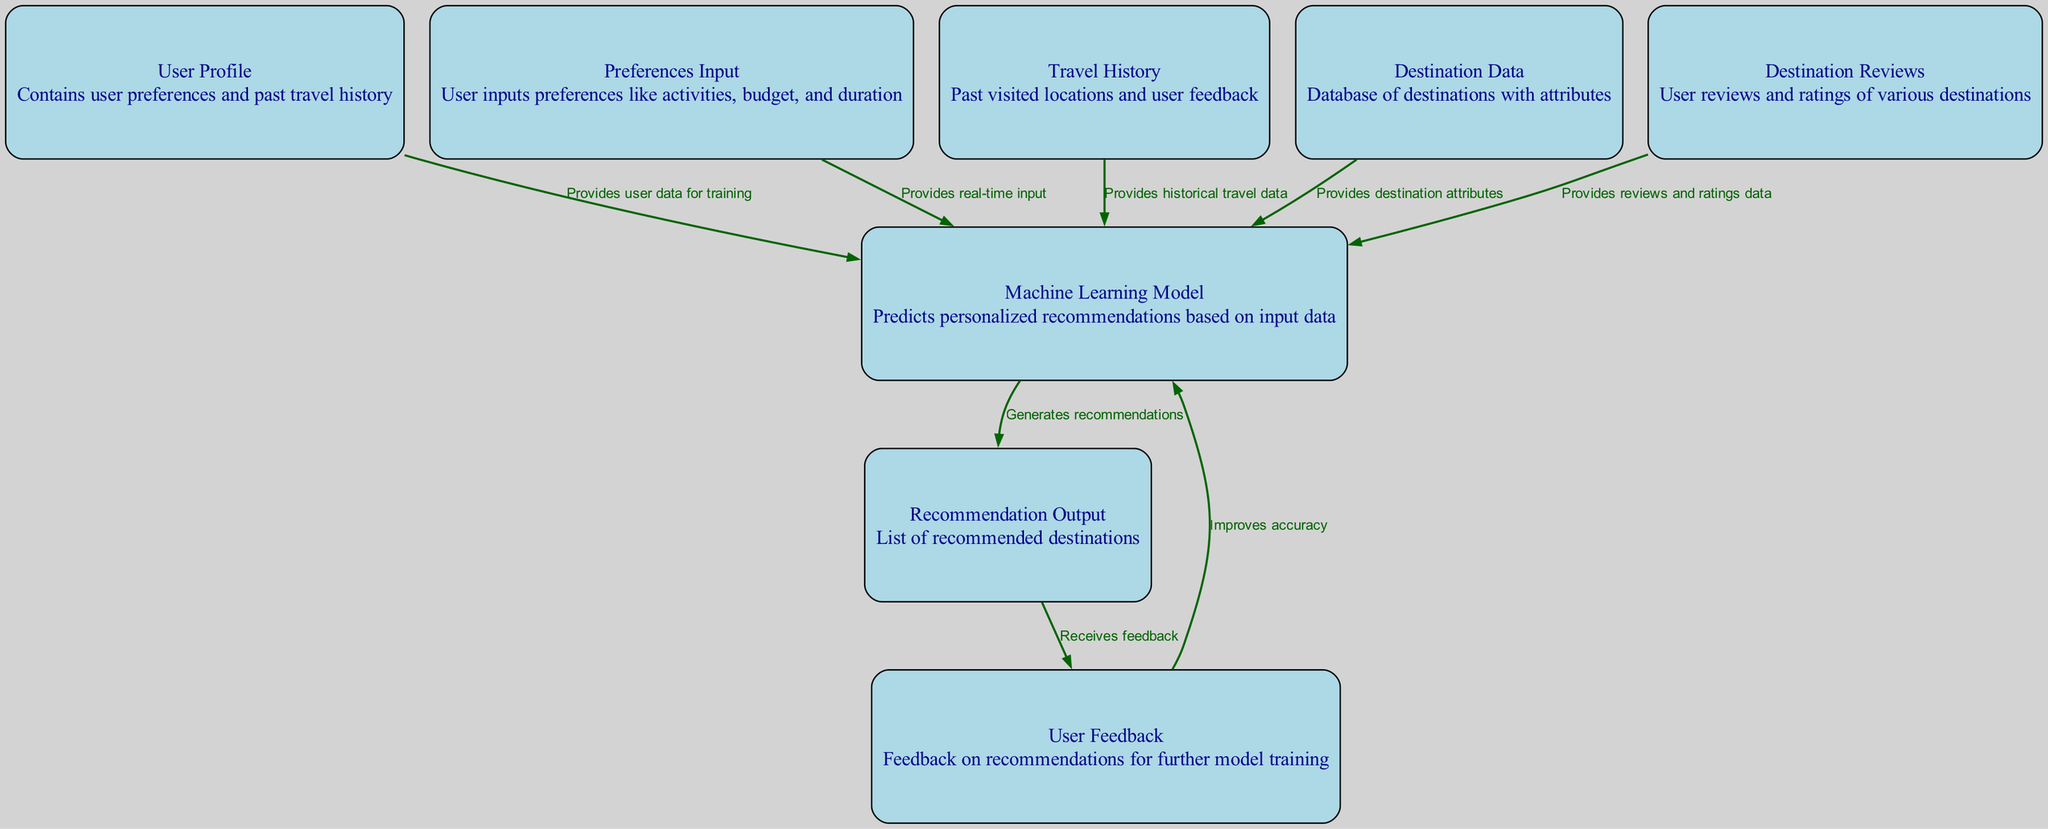What is the total number of nodes in the diagram? The diagram contains a total of 8 nodes representing different components of the travel recommendation system.
Answer: 8 What label corresponds to node "3"? Node "3" is labeled as "Travel History".
Answer: Travel History What does the "Machine Learning Model" do in this diagram? The "Machine Learning Model" generates personalized recommendations based on input data, serving as the central processing unit of the recommendation system.
Answer: Generates recommendations Which nodes provide input to the machine learning model? Nodes providing input to the machine learning model include "User Profile", "Preferences Input", "Travel History", "Destination Data", and "Destination Reviews".
Answer: User Profile, Preferences Input, Travel History, Destination Data, Destination Reviews What happens after the "Recommendation Output"? After the "Recommendation Output", user feedback is collected to further improve the machine learning model's accuracy through training.
Answer: Receives feedback How does user feedback affect the system? User feedback is used to improve the accuracy of the machine learning model, indicating a feedback loop where recommendations are refined based on user experiences.
Answer: Improves accuracy What type of data does the "Destination Data" node provide? The "Destination Data" node provides attributes of various destinations, such as location details and characteristics that help tailor recommendations.
Answer: Destination attributes How many edges connect to the "Machine Learning Model"? There are five edges connecting to the "Machine Learning Model", indicating various data inputs used for training and output generation.
Answer: 5 